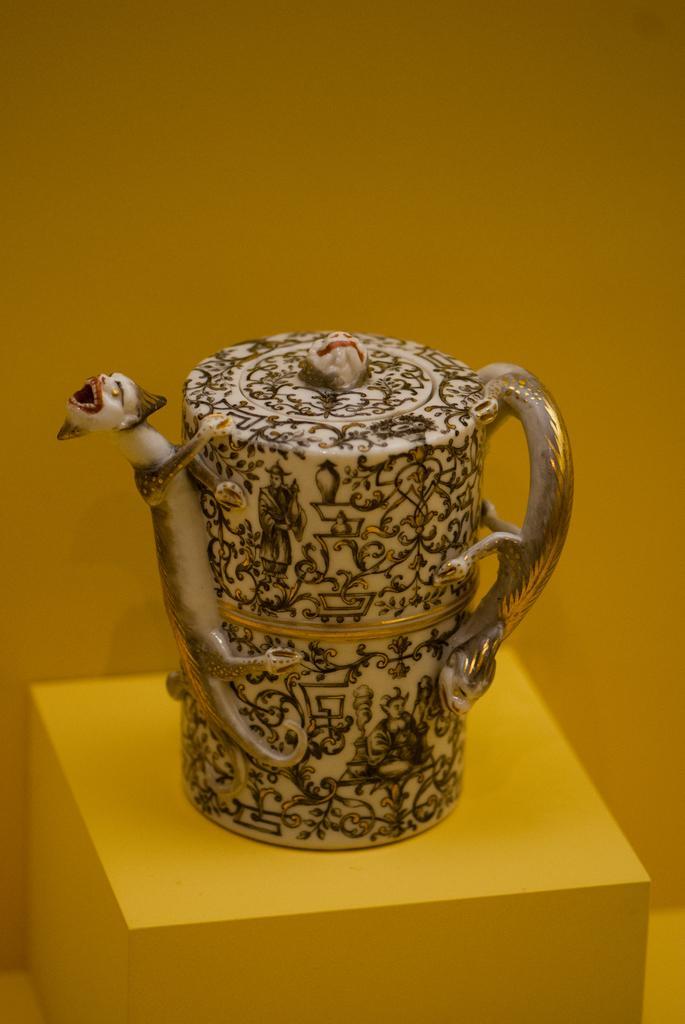How would you summarize this image in a sentence or two? In this image we can see a jug placed on the surface. In the background, we can see the wall. 